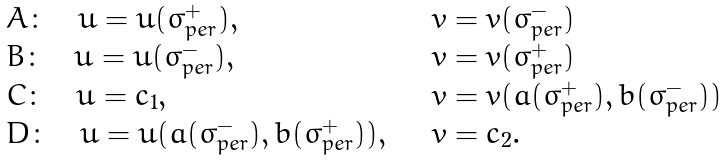Convert formula to latex. <formula><loc_0><loc_0><loc_500><loc_500>\begin{array} { l l } A \colon \quad u = u ( \sigma _ { p e r } ^ { + } ) , & \quad v = v ( \sigma _ { p e r } ^ { - } ) \\ B \colon \quad u = \bar { u } ( \sigma _ { p e r } ^ { - } ) , & \quad v = \bar { v } ( \sigma _ { p e r } ^ { + } ) \\ C \colon \quad u = c _ { 1 } , & \quad v = v ( \bar { a } ( \sigma _ { p e r } ^ { + } ) , \bar { b } ( \sigma _ { p e r } ^ { - } ) ) \\ D \colon \quad u = u ( a ( \sigma _ { p e r } ^ { - } ) , b ( \sigma _ { p e r } ^ { + } ) ) , & \quad v = c _ { 2 } . \end{array}</formula> 